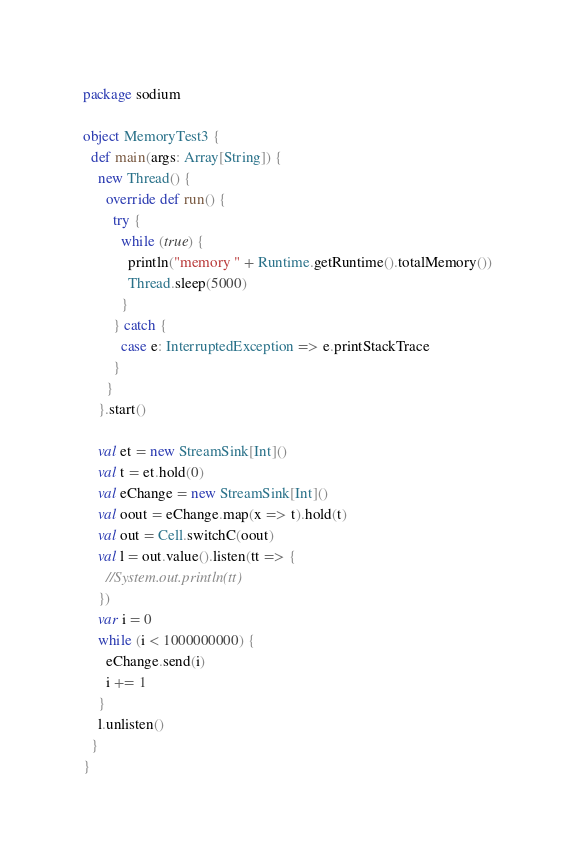<code> <loc_0><loc_0><loc_500><loc_500><_Scala_>package sodium

object MemoryTest3 {
  def main(args: Array[String]) {
    new Thread() {
      override def run() {
        try {
          while (true) {
            println("memory " + Runtime.getRuntime().totalMemory())
            Thread.sleep(5000)
          }
        } catch {
          case e: InterruptedException => e.printStackTrace
        }
      }
    }.start()

    val et = new StreamSink[Int]()
    val t = et.hold(0)
    val eChange = new StreamSink[Int]()
    val oout = eChange.map(x => t).hold(t)
    val out = Cell.switchC(oout)
    val l = out.value().listen(tt => {
      //System.out.println(tt)
    })
    var i = 0
    while (i < 1000000000) {
      eChange.send(i)
      i += 1
    }
    l.unlisten()
  }
}
</code> 